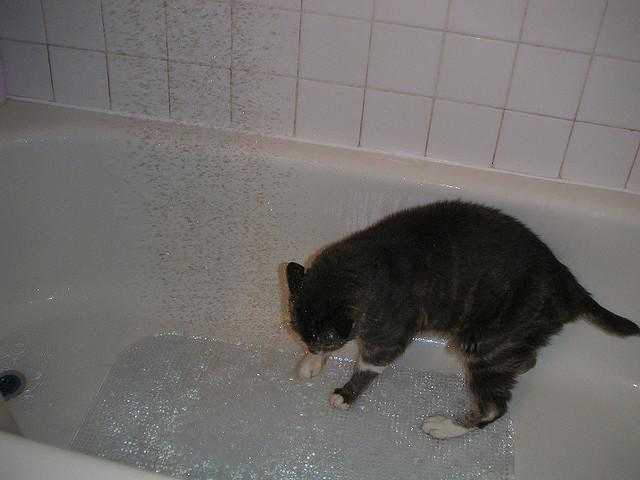What is the cat doing?
Write a very short answer. Sharpening nails. What is the cat standing in?
Keep it brief. Bathtub. Is the cat taking a shower?
Write a very short answer. No. 